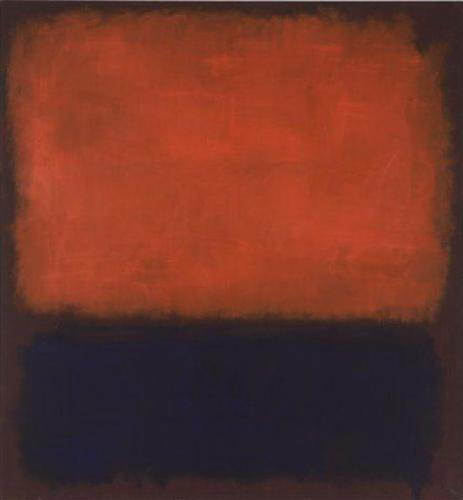What kind of music would best accompany this painting and why? Music with deep, resonant tones and a hint of melancholy would best accompany this painting. A piece like sharegpt4v/samuel Barber's 'Adagio for Strings' captures a similar blend of intensity and somberness. The slow, dramatic string arrangement would complement the bold red's fiery emotion while resonating with the black's profound solemnity, enhancing the viewer's introspective experience. 